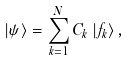<formula> <loc_0><loc_0><loc_500><loc_500>\left | \psi \right \rangle = \sum ^ { N } _ { k = 1 } C _ { k } \left | f _ { k } \right \rangle ,</formula> 